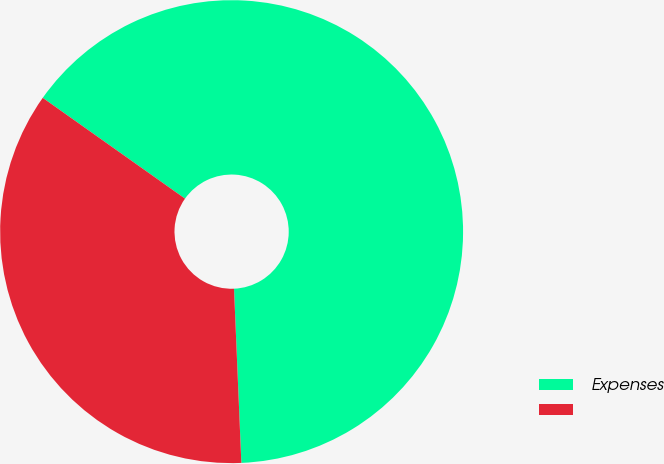Convert chart. <chart><loc_0><loc_0><loc_500><loc_500><pie_chart><fcel>Expenses<fcel>Unnamed: 1<nl><fcel>64.52%<fcel>35.48%<nl></chart> 